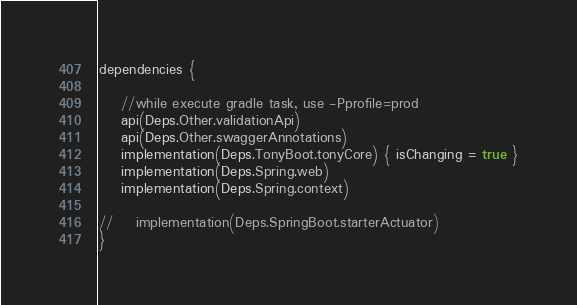<code> <loc_0><loc_0><loc_500><loc_500><_Kotlin_>dependencies {

    //while execute gradle task, use -Pprofile=prod
    api(Deps.Other.validationApi)
    api(Deps.Other.swaggerAnnotations)
    implementation(Deps.TonyBoot.tonyCore) { isChanging = true }
    implementation(Deps.Spring.web)
    implementation(Deps.Spring.context)

//    implementation(Deps.SpringBoot.starterActuator)
}
</code> 